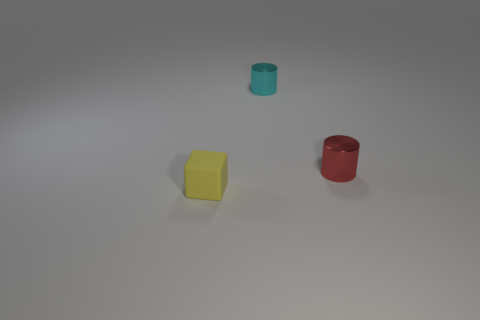Add 2 small yellow things. How many objects exist? 5 Subtract all cylinders. How many objects are left? 1 Subtract all brown metallic spheres. Subtract all metal cylinders. How many objects are left? 1 Add 1 red metal objects. How many red metal objects are left? 2 Add 3 tiny purple metal cylinders. How many tiny purple metal cylinders exist? 3 Subtract 0 yellow spheres. How many objects are left? 3 